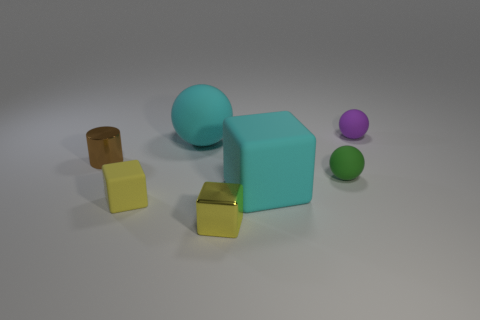What is the green sphere behind the large cyan matte object that is on the right side of the small block in front of the small rubber cube made of?
Your response must be concise. Rubber. Is the number of yellow cubes that are on the left side of the tiny purple rubber thing the same as the number of big gray metallic objects?
Offer a very short reply. No. Is the cyan thing in front of the small brown metal thing made of the same material as the small sphere that is behind the green object?
Make the answer very short. Yes. What number of things are cubes or rubber balls that are to the right of the brown metallic thing?
Ensure brevity in your answer.  6. Is there a yellow metal thing of the same shape as the purple matte thing?
Keep it short and to the point. No. What is the size of the cyan rubber thing behind the tiny ball in front of the tiny rubber object right of the green thing?
Offer a very short reply. Large. Are there an equal number of cyan things that are in front of the big cyan rubber ball and purple objects that are behind the tiny brown cylinder?
Ensure brevity in your answer.  Yes. What size is the yellow thing that is the same material as the brown cylinder?
Provide a short and direct response. Small. The tiny cylinder has what color?
Offer a very short reply. Brown. How many big matte balls have the same color as the metallic block?
Give a very brief answer. 0. 